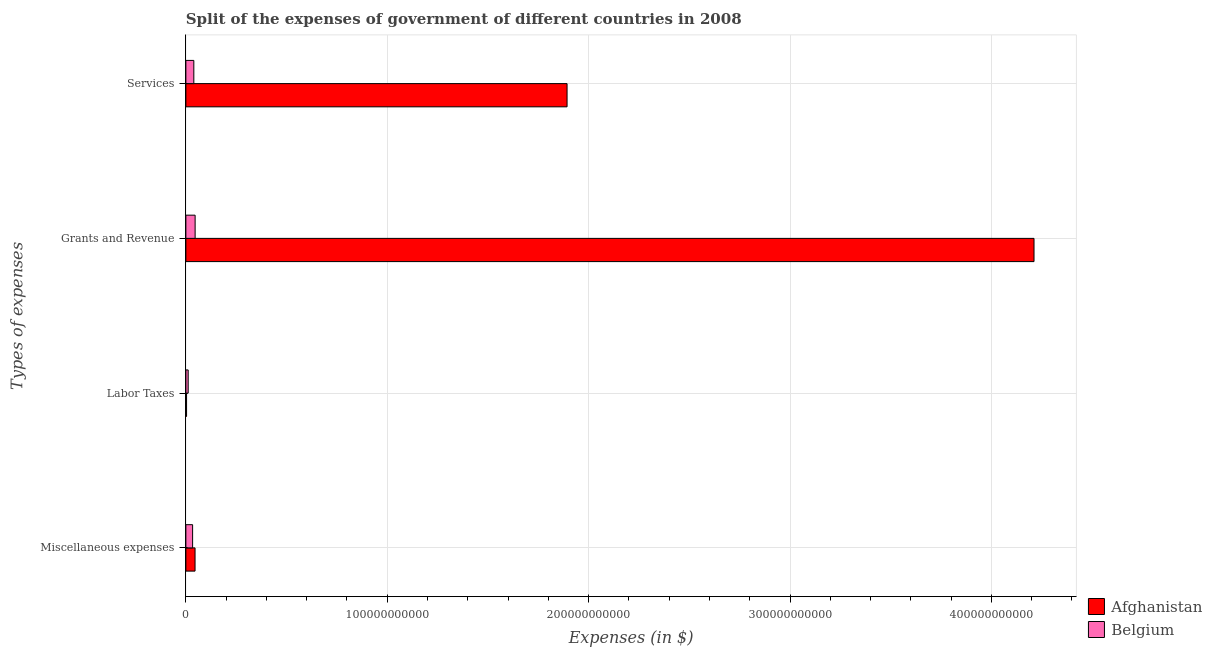How many groups of bars are there?
Give a very brief answer. 4. Are the number of bars per tick equal to the number of legend labels?
Make the answer very short. Yes. How many bars are there on the 3rd tick from the top?
Give a very brief answer. 2. How many bars are there on the 1st tick from the bottom?
Make the answer very short. 2. What is the label of the 4th group of bars from the top?
Make the answer very short. Miscellaneous expenses. What is the amount spent on miscellaneous expenses in Belgium?
Keep it short and to the point. 3.34e+09. Across all countries, what is the maximum amount spent on grants and revenue?
Ensure brevity in your answer.  4.21e+11. Across all countries, what is the minimum amount spent on grants and revenue?
Your answer should be compact. 4.59e+09. In which country was the amount spent on grants and revenue maximum?
Your response must be concise. Afghanistan. In which country was the amount spent on miscellaneous expenses minimum?
Provide a succinct answer. Belgium. What is the total amount spent on miscellaneous expenses in the graph?
Give a very brief answer. 7.90e+09. What is the difference between the amount spent on services in Belgium and that in Afghanistan?
Ensure brevity in your answer.  -1.85e+11. What is the difference between the amount spent on grants and revenue in Belgium and the amount spent on services in Afghanistan?
Offer a very short reply. -1.85e+11. What is the average amount spent on labor taxes per country?
Make the answer very short. 7.43e+08. What is the difference between the amount spent on services and amount spent on labor taxes in Afghanistan?
Provide a short and direct response. 1.89e+11. In how many countries, is the amount spent on labor taxes greater than 380000000000 $?
Offer a terse response. 0. What is the ratio of the amount spent on grants and revenue in Belgium to that in Afghanistan?
Give a very brief answer. 0.01. Is the amount spent on miscellaneous expenses in Belgium less than that in Afghanistan?
Keep it short and to the point. Yes. Is the difference between the amount spent on miscellaneous expenses in Belgium and Afghanistan greater than the difference between the amount spent on labor taxes in Belgium and Afghanistan?
Ensure brevity in your answer.  No. What is the difference between the highest and the second highest amount spent on labor taxes?
Your response must be concise. 8.04e+08. What is the difference between the highest and the lowest amount spent on services?
Offer a very short reply. 1.85e+11. Is the sum of the amount spent on grants and revenue in Belgium and Afghanistan greater than the maximum amount spent on miscellaneous expenses across all countries?
Your answer should be compact. Yes. Is it the case that in every country, the sum of the amount spent on grants and revenue and amount spent on labor taxes is greater than the sum of amount spent on miscellaneous expenses and amount spent on services?
Offer a terse response. Yes. What does the 1st bar from the top in Labor Taxes represents?
Offer a very short reply. Belgium. What does the 2nd bar from the bottom in Labor Taxes represents?
Provide a short and direct response. Belgium. Are all the bars in the graph horizontal?
Provide a succinct answer. Yes. What is the difference between two consecutive major ticks on the X-axis?
Provide a succinct answer. 1.00e+11. Are the values on the major ticks of X-axis written in scientific E-notation?
Keep it short and to the point. No. Does the graph contain any zero values?
Your response must be concise. No. How many legend labels are there?
Provide a succinct answer. 2. What is the title of the graph?
Make the answer very short. Split of the expenses of government of different countries in 2008. Does "Bosnia and Herzegovina" appear as one of the legend labels in the graph?
Provide a succinct answer. No. What is the label or title of the X-axis?
Provide a short and direct response. Expenses (in $). What is the label or title of the Y-axis?
Your answer should be compact. Types of expenses. What is the Expenses (in $) in Afghanistan in Miscellaneous expenses?
Offer a terse response. 4.55e+09. What is the Expenses (in $) in Belgium in Miscellaneous expenses?
Make the answer very short. 3.34e+09. What is the Expenses (in $) in Afghanistan in Labor Taxes?
Your answer should be very brief. 3.40e+08. What is the Expenses (in $) in Belgium in Labor Taxes?
Give a very brief answer. 1.14e+09. What is the Expenses (in $) of Afghanistan in Grants and Revenue?
Offer a terse response. 4.21e+11. What is the Expenses (in $) of Belgium in Grants and Revenue?
Provide a short and direct response. 4.59e+09. What is the Expenses (in $) of Afghanistan in Services?
Give a very brief answer. 1.89e+11. What is the Expenses (in $) of Belgium in Services?
Your answer should be very brief. 3.95e+09. Across all Types of expenses, what is the maximum Expenses (in $) of Afghanistan?
Your answer should be compact. 4.21e+11. Across all Types of expenses, what is the maximum Expenses (in $) in Belgium?
Your answer should be very brief. 4.59e+09. Across all Types of expenses, what is the minimum Expenses (in $) in Afghanistan?
Your response must be concise. 3.40e+08. Across all Types of expenses, what is the minimum Expenses (in $) in Belgium?
Ensure brevity in your answer.  1.14e+09. What is the total Expenses (in $) of Afghanistan in the graph?
Make the answer very short. 6.15e+11. What is the total Expenses (in $) in Belgium in the graph?
Provide a succinct answer. 1.30e+1. What is the difference between the Expenses (in $) of Afghanistan in Miscellaneous expenses and that in Labor Taxes?
Offer a terse response. 4.21e+09. What is the difference between the Expenses (in $) of Belgium in Miscellaneous expenses and that in Labor Taxes?
Ensure brevity in your answer.  2.20e+09. What is the difference between the Expenses (in $) in Afghanistan in Miscellaneous expenses and that in Grants and Revenue?
Keep it short and to the point. -4.17e+11. What is the difference between the Expenses (in $) in Belgium in Miscellaneous expenses and that in Grants and Revenue?
Offer a terse response. -1.25e+09. What is the difference between the Expenses (in $) of Afghanistan in Miscellaneous expenses and that in Services?
Your answer should be very brief. -1.85e+11. What is the difference between the Expenses (in $) in Belgium in Miscellaneous expenses and that in Services?
Ensure brevity in your answer.  -6.06e+08. What is the difference between the Expenses (in $) in Afghanistan in Labor Taxes and that in Grants and Revenue?
Your answer should be very brief. -4.21e+11. What is the difference between the Expenses (in $) in Belgium in Labor Taxes and that in Grants and Revenue?
Provide a short and direct response. -3.45e+09. What is the difference between the Expenses (in $) of Afghanistan in Labor Taxes and that in Services?
Provide a short and direct response. -1.89e+11. What is the difference between the Expenses (in $) of Belgium in Labor Taxes and that in Services?
Offer a terse response. -2.80e+09. What is the difference between the Expenses (in $) of Afghanistan in Grants and Revenue and that in Services?
Make the answer very short. 2.32e+11. What is the difference between the Expenses (in $) in Belgium in Grants and Revenue and that in Services?
Your response must be concise. 6.43e+08. What is the difference between the Expenses (in $) in Afghanistan in Miscellaneous expenses and the Expenses (in $) in Belgium in Labor Taxes?
Give a very brief answer. 3.41e+09. What is the difference between the Expenses (in $) of Afghanistan in Miscellaneous expenses and the Expenses (in $) of Belgium in Grants and Revenue?
Your response must be concise. -3.82e+07. What is the difference between the Expenses (in $) in Afghanistan in Miscellaneous expenses and the Expenses (in $) in Belgium in Services?
Make the answer very short. 6.05e+08. What is the difference between the Expenses (in $) in Afghanistan in Labor Taxes and the Expenses (in $) in Belgium in Grants and Revenue?
Your response must be concise. -4.25e+09. What is the difference between the Expenses (in $) in Afghanistan in Labor Taxes and the Expenses (in $) in Belgium in Services?
Your response must be concise. -3.61e+09. What is the difference between the Expenses (in $) in Afghanistan in Grants and Revenue and the Expenses (in $) in Belgium in Services?
Provide a succinct answer. 4.17e+11. What is the average Expenses (in $) in Afghanistan per Types of expenses?
Offer a terse response. 1.54e+11. What is the average Expenses (in $) of Belgium per Types of expenses?
Offer a very short reply. 3.26e+09. What is the difference between the Expenses (in $) in Afghanistan and Expenses (in $) in Belgium in Miscellaneous expenses?
Offer a very short reply. 1.21e+09. What is the difference between the Expenses (in $) in Afghanistan and Expenses (in $) in Belgium in Labor Taxes?
Ensure brevity in your answer.  -8.04e+08. What is the difference between the Expenses (in $) of Afghanistan and Expenses (in $) of Belgium in Grants and Revenue?
Provide a short and direct response. 4.17e+11. What is the difference between the Expenses (in $) of Afghanistan and Expenses (in $) of Belgium in Services?
Provide a succinct answer. 1.85e+11. What is the ratio of the Expenses (in $) in Afghanistan in Miscellaneous expenses to that in Labor Taxes?
Make the answer very short. 13.38. What is the ratio of the Expenses (in $) of Belgium in Miscellaneous expenses to that in Labor Taxes?
Offer a terse response. 2.92. What is the ratio of the Expenses (in $) of Afghanistan in Miscellaneous expenses to that in Grants and Revenue?
Ensure brevity in your answer.  0.01. What is the ratio of the Expenses (in $) in Belgium in Miscellaneous expenses to that in Grants and Revenue?
Give a very brief answer. 0.73. What is the ratio of the Expenses (in $) of Afghanistan in Miscellaneous expenses to that in Services?
Keep it short and to the point. 0.02. What is the ratio of the Expenses (in $) in Belgium in Miscellaneous expenses to that in Services?
Your response must be concise. 0.85. What is the ratio of the Expenses (in $) of Afghanistan in Labor Taxes to that in Grants and Revenue?
Give a very brief answer. 0. What is the ratio of the Expenses (in $) of Belgium in Labor Taxes to that in Grants and Revenue?
Offer a terse response. 0.25. What is the ratio of the Expenses (in $) in Afghanistan in Labor Taxes to that in Services?
Your response must be concise. 0. What is the ratio of the Expenses (in $) of Belgium in Labor Taxes to that in Services?
Offer a very short reply. 0.29. What is the ratio of the Expenses (in $) in Afghanistan in Grants and Revenue to that in Services?
Offer a very short reply. 2.23. What is the ratio of the Expenses (in $) in Belgium in Grants and Revenue to that in Services?
Offer a very short reply. 1.16. What is the difference between the highest and the second highest Expenses (in $) in Afghanistan?
Give a very brief answer. 2.32e+11. What is the difference between the highest and the second highest Expenses (in $) of Belgium?
Ensure brevity in your answer.  6.43e+08. What is the difference between the highest and the lowest Expenses (in $) of Afghanistan?
Give a very brief answer. 4.21e+11. What is the difference between the highest and the lowest Expenses (in $) of Belgium?
Provide a short and direct response. 3.45e+09. 